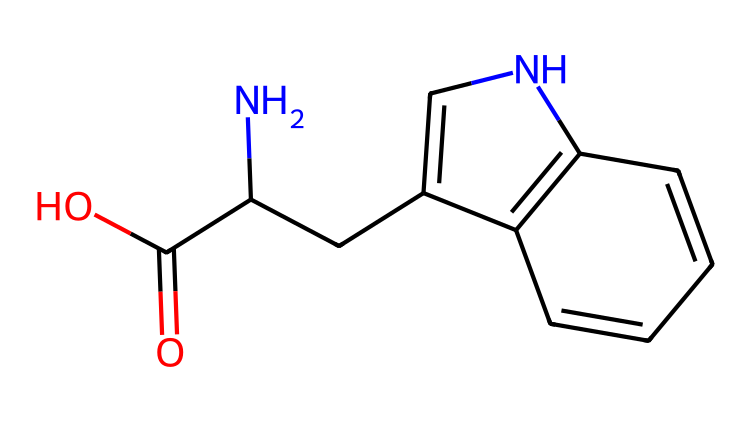What is the total number of carbon atoms in the structure? By analyzing the SMILES representation, I can count the carbon atoms present. Each "C" symbol in the structure represents a carbon atom. In this case, there are ten instances of "C" in the SMILES notation.
Answer: ten How many nitrogen atoms are present in the compound? In the SMILES representation, the "N" notation indicates the presence of a nitrogen atom. A careful scan reveals there are two "N" symbols in the structure.
Answer: two What functional group is present in this chemical? The presence of "C(=O)O" in the SMILES indicates a carboxylic acid functional group, as it consists of a carbonyl (C=O) and a hydroxyl group (–OH). This particular arrangement defines the compound's acidic nature.
Answer: carboxylic acid What type of ring structure is indicated in the chemical's structure? The presence of "C1" and "C2" in the SMILES denotes that there are aromatic ring structures, indicating that these carbon atoms are part of a cyclic arrangement. The ring includes alternating double bonds, typical of aromatic systems.
Answer: aromatic What is the main role of serotonin in the body? Serotonin is primarily known for its role as a neurotransmitter that regulates mood, anxiety, and happiness. This function is essential for mental health and emotional well-being.
Answer: mood regulation How does the presence of nitrogen influence the behavior of this chemical? The nitrogen atoms in the structure can donate electrons, which is a fundamental property influencing its reactivity and interaction with receptors in the brain, crucial for its function in mood regulation as a neurotransmitter.
Answer: reactivity What element differentiates this neurotransmitter from others? The nitrogen atoms set serotonin apart from many other neurotransmitters, which may be solely composed of carbon, hydrogen, and oxygen. The inclusion of nitrogen enables it to function differently in signaling processes within the nervous system.
Answer: nitrogen 